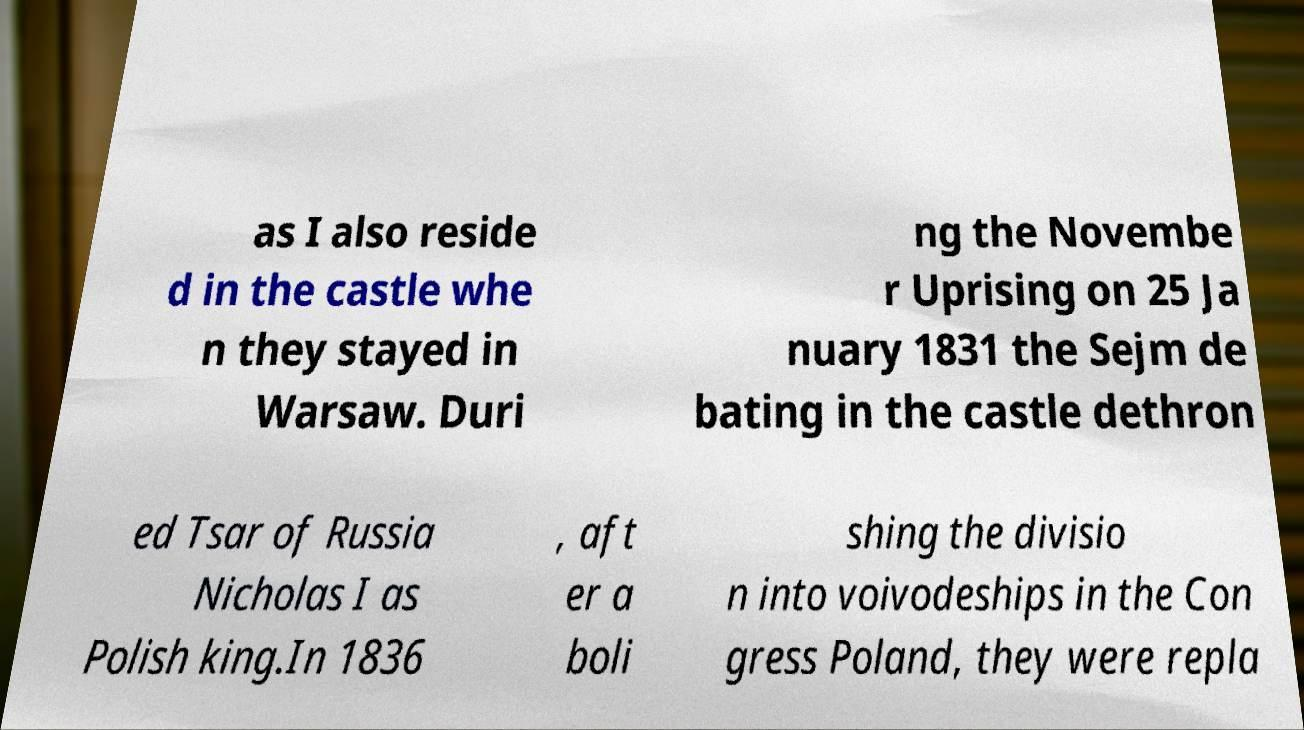Please identify and transcribe the text found in this image. as I also reside d in the castle whe n they stayed in Warsaw. Duri ng the Novembe r Uprising on 25 Ja nuary 1831 the Sejm de bating in the castle dethron ed Tsar of Russia Nicholas I as Polish king.In 1836 , aft er a boli shing the divisio n into voivodeships in the Con gress Poland, they were repla 